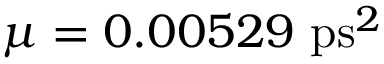<formula> <loc_0><loc_0><loc_500><loc_500>\mu = 0 . 0 0 5 2 9 p s ^ { 2 }</formula> 